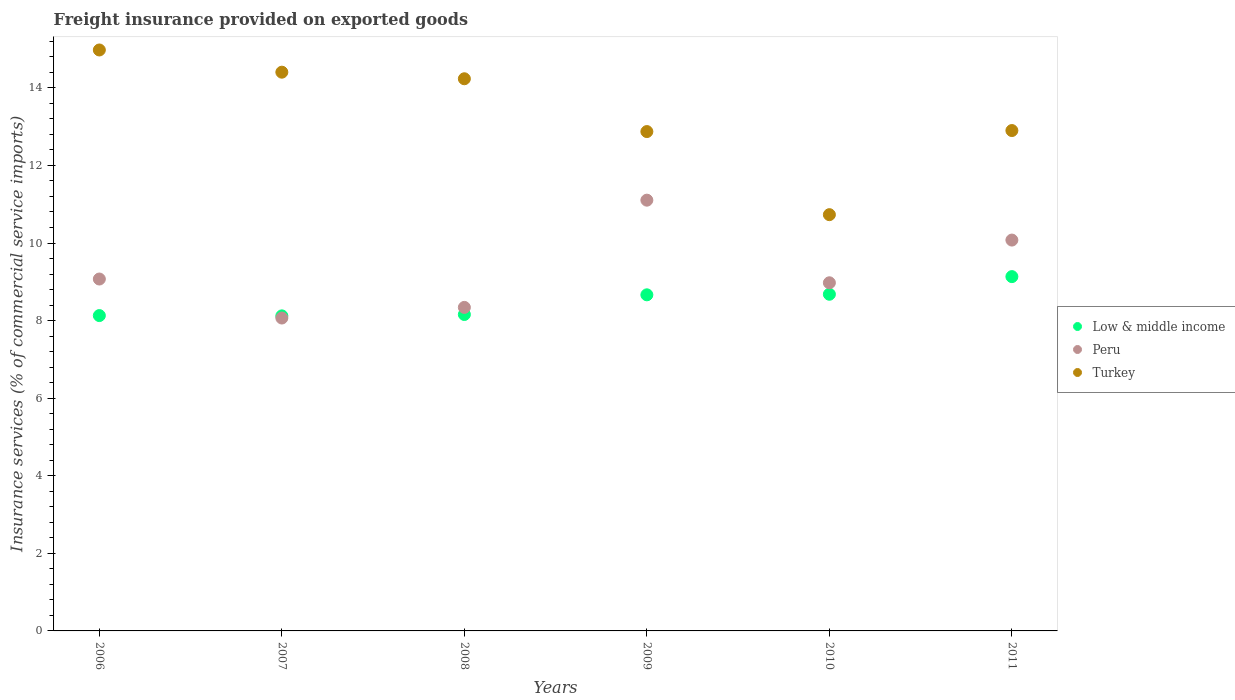What is the freight insurance provided on exported goods in Low & middle income in 2009?
Keep it short and to the point. 8.66. Across all years, what is the maximum freight insurance provided on exported goods in Low & middle income?
Make the answer very short. 9.13. Across all years, what is the minimum freight insurance provided on exported goods in Peru?
Make the answer very short. 8.07. What is the total freight insurance provided on exported goods in Peru in the graph?
Your response must be concise. 55.64. What is the difference between the freight insurance provided on exported goods in Peru in 2008 and that in 2010?
Offer a very short reply. -0.63. What is the difference between the freight insurance provided on exported goods in Turkey in 2006 and the freight insurance provided on exported goods in Peru in 2009?
Keep it short and to the point. 3.87. What is the average freight insurance provided on exported goods in Turkey per year?
Ensure brevity in your answer.  13.35. In the year 2009, what is the difference between the freight insurance provided on exported goods in Peru and freight insurance provided on exported goods in Low & middle income?
Ensure brevity in your answer.  2.44. What is the ratio of the freight insurance provided on exported goods in Peru in 2007 to that in 2009?
Your response must be concise. 0.73. Is the freight insurance provided on exported goods in Low & middle income in 2007 less than that in 2008?
Provide a succinct answer. Yes. What is the difference between the highest and the second highest freight insurance provided on exported goods in Turkey?
Offer a very short reply. 0.57. What is the difference between the highest and the lowest freight insurance provided on exported goods in Low & middle income?
Your answer should be very brief. 1.01. Is the sum of the freight insurance provided on exported goods in Peru in 2007 and 2010 greater than the maximum freight insurance provided on exported goods in Low & middle income across all years?
Make the answer very short. Yes. Does the freight insurance provided on exported goods in Low & middle income monotonically increase over the years?
Your answer should be compact. No. Is the freight insurance provided on exported goods in Low & middle income strictly greater than the freight insurance provided on exported goods in Turkey over the years?
Give a very brief answer. No. Does the graph contain any zero values?
Your answer should be compact. No. Does the graph contain grids?
Offer a very short reply. No. How are the legend labels stacked?
Make the answer very short. Vertical. What is the title of the graph?
Provide a succinct answer. Freight insurance provided on exported goods. Does "Isle of Man" appear as one of the legend labels in the graph?
Ensure brevity in your answer.  No. What is the label or title of the X-axis?
Offer a terse response. Years. What is the label or title of the Y-axis?
Your answer should be very brief. Insurance services (% of commercial service imports). What is the Insurance services (% of commercial service imports) of Low & middle income in 2006?
Offer a terse response. 8.13. What is the Insurance services (% of commercial service imports) of Peru in 2006?
Provide a short and direct response. 9.07. What is the Insurance services (% of commercial service imports) in Turkey in 2006?
Make the answer very short. 14.98. What is the Insurance services (% of commercial service imports) of Low & middle income in 2007?
Make the answer very short. 8.12. What is the Insurance services (% of commercial service imports) in Peru in 2007?
Your response must be concise. 8.07. What is the Insurance services (% of commercial service imports) in Turkey in 2007?
Provide a short and direct response. 14.4. What is the Insurance services (% of commercial service imports) in Low & middle income in 2008?
Your response must be concise. 8.16. What is the Insurance services (% of commercial service imports) of Peru in 2008?
Keep it short and to the point. 8.34. What is the Insurance services (% of commercial service imports) of Turkey in 2008?
Your answer should be compact. 14.23. What is the Insurance services (% of commercial service imports) of Low & middle income in 2009?
Make the answer very short. 8.66. What is the Insurance services (% of commercial service imports) of Peru in 2009?
Ensure brevity in your answer.  11.1. What is the Insurance services (% of commercial service imports) in Turkey in 2009?
Make the answer very short. 12.87. What is the Insurance services (% of commercial service imports) of Low & middle income in 2010?
Make the answer very short. 8.68. What is the Insurance services (% of commercial service imports) of Peru in 2010?
Ensure brevity in your answer.  8.98. What is the Insurance services (% of commercial service imports) in Turkey in 2010?
Offer a terse response. 10.73. What is the Insurance services (% of commercial service imports) of Low & middle income in 2011?
Provide a succinct answer. 9.13. What is the Insurance services (% of commercial service imports) of Peru in 2011?
Provide a succinct answer. 10.08. What is the Insurance services (% of commercial service imports) of Turkey in 2011?
Make the answer very short. 12.9. Across all years, what is the maximum Insurance services (% of commercial service imports) of Low & middle income?
Ensure brevity in your answer.  9.13. Across all years, what is the maximum Insurance services (% of commercial service imports) of Peru?
Give a very brief answer. 11.1. Across all years, what is the maximum Insurance services (% of commercial service imports) of Turkey?
Your answer should be very brief. 14.98. Across all years, what is the minimum Insurance services (% of commercial service imports) of Low & middle income?
Ensure brevity in your answer.  8.12. Across all years, what is the minimum Insurance services (% of commercial service imports) in Peru?
Provide a succinct answer. 8.07. Across all years, what is the minimum Insurance services (% of commercial service imports) of Turkey?
Your answer should be very brief. 10.73. What is the total Insurance services (% of commercial service imports) of Low & middle income in the graph?
Ensure brevity in your answer.  50.89. What is the total Insurance services (% of commercial service imports) of Peru in the graph?
Your answer should be compact. 55.64. What is the total Insurance services (% of commercial service imports) of Turkey in the graph?
Offer a very short reply. 80.12. What is the difference between the Insurance services (% of commercial service imports) of Low & middle income in 2006 and that in 2007?
Make the answer very short. 0.01. What is the difference between the Insurance services (% of commercial service imports) of Peru in 2006 and that in 2007?
Your answer should be very brief. 1.01. What is the difference between the Insurance services (% of commercial service imports) in Turkey in 2006 and that in 2007?
Provide a short and direct response. 0.57. What is the difference between the Insurance services (% of commercial service imports) of Low & middle income in 2006 and that in 2008?
Offer a very short reply. -0.03. What is the difference between the Insurance services (% of commercial service imports) in Peru in 2006 and that in 2008?
Ensure brevity in your answer.  0.73. What is the difference between the Insurance services (% of commercial service imports) in Turkey in 2006 and that in 2008?
Keep it short and to the point. 0.74. What is the difference between the Insurance services (% of commercial service imports) in Low & middle income in 2006 and that in 2009?
Keep it short and to the point. -0.54. What is the difference between the Insurance services (% of commercial service imports) in Peru in 2006 and that in 2009?
Your answer should be very brief. -2.03. What is the difference between the Insurance services (% of commercial service imports) of Turkey in 2006 and that in 2009?
Your answer should be very brief. 2.1. What is the difference between the Insurance services (% of commercial service imports) of Low & middle income in 2006 and that in 2010?
Your answer should be very brief. -0.55. What is the difference between the Insurance services (% of commercial service imports) of Peru in 2006 and that in 2010?
Offer a very short reply. 0.1. What is the difference between the Insurance services (% of commercial service imports) in Turkey in 2006 and that in 2010?
Provide a short and direct response. 4.25. What is the difference between the Insurance services (% of commercial service imports) in Low & middle income in 2006 and that in 2011?
Keep it short and to the point. -1. What is the difference between the Insurance services (% of commercial service imports) of Peru in 2006 and that in 2011?
Keep it short and to the point. -1. What is the difference between the Insurance services (% of commercial service imports) of Turkey in 2006 and that in 2011?
Keep it short and to the point. 2.08. What is the difference between the Insurance services (% of commercial service imports) of Low & middle income in 2007 and that in 2008?
Your response must be concise. -0.04. What is the difference between the Insurance services (% of commercial service imports) of Peru in 2007 and that in 2008?
Offer a very short reply. -0.27. What is the difference between the Insurance services (% of commercial service imports) of Turkey in 2007 and that in 2008?
Offer a very short reply. 0.17. What is the difference between the Insurance services (% of commercial service imports) in Low & middle income in 2007 and that in 2009?
Offer a terse response. -0.54. What is the difference between the Insurance services (% of commercial service imports) in Peru in 2007 and that in 2009?
Keep it short and to the point. -3.04. What is the difference between the Insurance services (% of commercial service imports) in Turkey in 2007 and that in 2009?
Your answer should be very brief. 1.53. What is the difference between the Insurance services (% of commercial service imports) in Low & middle income in 2007 and that in 2010?
Provide a succinct answer. -0.56. What is the difference between the Insurance services (% of commercial service imports) in Peru in 2007 and that in 2010?
Offer a very short reply. -0.91. What is the difference between the Insurance services (% of commercial service imports) of Turkey in 2007 and that in 2010?
Your response must be concise. 3.67. What is the difference between the Insurance services (% of commercial service imports) of Low & middle income in 2007 and that in 2011?
Offer a very short reply. -1.01. What is the difference between the Insurance services (% of commercial service imports) of Peru in 2007 and that in 2011?
Give a very brief answer. -2.01. What is the difference between the Insurance services (% of commercial service imports) in Turkey in 2007 and that in 2011?
Offer a terse response. 1.5. What is the difference between the Insurance services (% of commercial service imports) of Low & middle income in 2008 and that in 2009?
Provide a short and direct response. -0.51. What is the difference between the Insurance services (% of commercial service imports) of Peru in 2008 and that in 2009?
Provide a succinct answer. -2.76. What is the difference between the Insurance services (% of commercial service imports) of Turkey in 2008 and that in 2009?
Offer a terse response. 1.36. What is the difference between the Insurance services (% of commercial service imports) in Low & middle income in 2008 and that in 2010?
Offer a terse response. -0.52. What is the difference between the Insurance services (% of commercial service imports) of Peru in 2008 and that in 2010?
Make the answer very short. -0.63. What is the difference between the Insurance services (% of commercial service imports) in Turkey in 2008 and that in 2010?
Provide a succinct answer. 3.5. What is the difference between the Insurance services (% of commercial service imports) in Low & middle income in 2008 and that in 2011?
Your response must be concise. -0.98. What is the difference between the Insurance services (% of commercial service imports) in Peru in 2008 and that in 2011?
Provide a short and direct response. -1.74. What is the difference between the Insurance services (% of commercial service imports) of Turkey in 2008 and that in 2011?
Your answer should be very brief. 1.33. What is the difference between the Insurance services (% of commercial service imports) of Low & middle income in 2009 and that in 2010?
Your answer should be very brief. -0.01. What is the difference between the Insurance services (% of commercial service imports) of Peru in 2009 and that in 2010?
Give a very brief answer. 2.13. What is the difference between the Insurance services (% of commercial service imports) of Turkey in 2009 and that in 2010?
Make the answer very short. 2.14. What is the difference between the Insurance services (% of commercial service imports) of Low & middle income in 2009 and that in 2011?
Your answer should be compact. -0.47. What is the difference between the Insurance services (% of commercial service imports) in Peru in 2009 and that in 2011?
Provide a succinct answer. 1.03. What is the difference between the Insurance services (% of commercial service imports) in Turkey in 2009 and that in 2011?
Your answer should be very brief. -0.03. What is the difference between the Insurance services (% of commercial service imports) in Low & middle income in 2010 and that in 2011?
Provide a short and direct response. -0.45. What is the difference between the Insurance services (% of commercial service imports) in Peru in 2010 and that in 2011?
Make the answer very short. -1.1. What is the difference between the Insurance services (% of commercial service imports) in Turkey in 2010 and that in 2011?
Your answer should be very brief. -2.17. What is the difference between the Insurance services (% of commercial service imports) of Low & middle income in 2006 and the Insurance services (% of commercial service imports) of Peru in 2007?
Your answer should be very brief. 0.06. What is the difference between the Insurance services (% of commercial service imports) in Low & middle income in 2006 and the Insurance services (% of commercial service imports) in Turkey in 2007?
Make the answer very short. -6.27. What is the difference between the Insurance services (% of commercial service imports) of Peru in 2006 and the Insurance services (% of commercial service imports) of Turkey in 2007?
Your answer should be compact. -5.33. What is the difference between the Insurance services (% of commercial service imports) of Low & middle income in 2006 and the Insurance services (% of commercial service imports) of Peru in 2008?
Offer a terse response. -0.21. What is the difference between the Insurance services (% of commercial service imports) in Low & middle income in 2006 and the Insurance services (% of commercial service imports) in Turkey in 2008?
Your answer should be compact. -6.11. What is the difference between the Insurance services (% of commercial service imports) in Peru in 2006 and the Insurance services (% of commercial service imports) in Turkey in 2008?
Make the answer very short. -5.16. What is the difference between the Insurance services (% of commercial service imports) in Low & middle income in 2006 and the Insurance services (% of commercial service imports) in Peru in 2009?
Give a very brief answer. -2.98. What is the difference between the Insurance services (% of commercial service imports) in Low & middle income in 2006 and the Insurance services (% of commercial service imports) in Turkey in 2009?
Make the answer very short. -4.74. What is the difference between the Insurance services (% of commercial service imports) of Peru in 2006 and the Insurance services (% of commercial service imports) of Turkey in 2009?
Provide a short and direct response. -3.8. What is the difference between the Insurance services (% of commercial service imports) in Low & middle income in 2006 and the Insurance services (% of commercial service imports) in Peru in 2010?
Keep it short and to the point. -0.85. What is the difference between the Insurance services (% of commercial service imports) in Low & middle income in 2006 and the Insurance services (% of commercial service imports) in Turkey in 2010?
Ensure brevity in your answer.  -2.6. What is the difference between the Insurance services (% of commercial service imports) in Peru in 2006 and the Insurance services (% of commercial service imports) in Turkey in 2010?
Provide a short and direct response. -1.66. What is the difference between the Insurance services (% of commercial service imports) in Low & middle income in 2006 and the Insurance services (% of commercial service imports) in Peru in 2011?
Ensure brevity in your answer.  -1.95. What is the difference between the Insurance services (% of commercial service imports) of Low & middle income in 2006 and the Insurance services (% of commercial service imports) of Turkey in 2011?
Offer a terse response. -4.77. What is the difference between the Insurance services (% of commercial service imports) of Peru in 2006 and the Insurance services (% of commercial service imports) of Turkey in 2011?
Offer a terse response. -3.83. What is the difference between the Insurance services (% of commercial service imports) in Low & middle income in 2007 and the Insurance services (% of commercial service imports) in Peru in 2008?
Your response must be concise. -0.22. What is the difference between the Insurance services (% of commercial service imports) of Low & middle income in 2007 and the Insurance services (% of commercial service imports) of Turkey in 2008?
Your answer should be compact. -6.11. What is the difference between the Insurance services (% of commercial service imports) of Peru in 2007 and the Insurance services (% of commercial service imports) of Turkey in 2008?
Your answer should be compact. -6.17. What is the difference between the Insurance services (% of commercial service imports) in Low & middle income in 2007 and the Insurance services (% of commercial service imports) in Peru in 2009?
Keep it short and to the point. -2.98. What is the difference between the Insurance services (% of commercial service imports) in Low & middle income in 2007 and the Insurance services (% of commercial service imports) in Turkey in 2009?
Your answer should be compact. -4.75. What is the difference between the Insurance services (% of commercial service imports) of Peru in 2007 and the Insurance services (% of commercial service imports) of Turkey in 2009?
Offer a very short reply. -4.81. What is the difference between the Insurance services (% of commercial service imports) in Low & middle income in 2007 and the Insurance services (% of commercial service imports) in Peru in 2010?
Your response must be concise. -0.85. What is the difference between the Insurance services (% of commercial service imports) of Low & middle income in 2007 and the Insurance services (% of commercial service imports) of Turkey in 2010?
Provide a succinct answer. -2.61. What is the difference between the Insurance services (% of commercial service imports) of Peru in 2007 and the Insurance services (% of commercial service imports) of Turkey in 2010?
Provide a short and direct response. -2.66. What is the difference between the Insurance services (% of commercial service imports) in Low & middle income in 2007 and the Insurance services (% of commercial service imports) in Peru in 2011?
Offer a terse response. -1.95. What is the difference between the Insurance services (% of commercial service imports) of Low & middle income in 2007 and the Insurance services (% of commercial service imports) of Turkey in 2011?
Offer a very short reply. -4.78. What is the difference between the Insurance services (% of commercial service imports) in Peru in 2007 and the Insurance services (% of commercial service imports) in Turkey in 2011?
Keep it short and to the point. -4.83. What is the difference between the Insurance services (% of commercial service imports) of Low & middle income in 2008 and the Insurance services (% of commercial service imports) of Peru in 2009?
Offer a very short reply. -2.95. What is the difference between the Insurance services (% of commercial service imports) in Low & middle income in 2008 and the Insurance services (% of commercial service imports) in Turkey in 2009?
Offer a very short reply. -4.72. What is the difference between the Insurance services (% of commercial service imports) in Peru in 2008 and the Insurance services (% of commercial service imports) in Turkey in 2009?
Your answer should be very brief. -4.53. What is the difference between the Insurance services (% of commercial service imports) in Low & middle income in 2008 and the Insurance services (% of commercial service imports) in Peru in 2010?
Make the answer very short. -0.82. What is the difference between the Insurance services (% of commercial service imports) in Low & middle income in 2008 and the Insurance services (% of commercial service imports) in Turkey in 2010?
Your response must be concise. -2.57. What is the difference between the Insurance services (% of commercial service imports) of Peru in 2008 and the Insurance services (% of commercial service imports) of Turkey in 2010?
Offer a very short reply. -2.39. What is the difference between the Insurance services (% of commercial service imports) of Low & middle income in 2008 and the Insurance services (% of commercial service imports) of Peru in 2011?
Provide a succinct answer. -1.92. What is the difference between the Insurance services (% of commercial service imports) in Low & middle income in 2008 and the Insurance services (% of commercial service imports) in Turkey in 2011?
Give a very brief answer. -4.74. What is the difference between the Insurance services (% of commercial service imports) in Peru in 2008 and the Insurance services (% of commercial service imports) in Turkey in 2011?
Provide a short and direct response. -4.56. What is the difference between the Insurance services (% of commercial service imports) in Low & middle income in 2009 and the Insurance services (% of commercial service imports) in Peru in 2010?
Offer a very short reply. -0.31. What is the difference between the Insurance services (% of commercial service imports) in Low & middle income in 2009 and the Insurance services (% of commercial service imports) in Turkey in 2010?
Keep it short and to the point. -2.07. What is the difference between the Insurance services (% of commercial service imports) of Peru in 2009 and the Insurance services (% of commercial service imports) of Turkey in 2010?
Provide a short and direct response. 0.37. What is the difference between the Insurance services (% of commercial service imports) of Low & middle income in 2009 and the Insurance services (% of commercial service imports) of Peru in 2011?
Make the answer very short. -1.41. What is the difference between the Insurance services (% of commercial service imports) of Low & middle income in 2009 and the Insurance services (% of commercial service imports) of Turkey in 2011?
Your answer should be very brief. -4.24. What is the difference between the Insurance services (% of commercial service imports) in Peru in 2009 and the Insurance services (% of commercial service imports) in Turkey in 2011?
Make the answer very short. -1.79. What is the difference between the Insurance services (% of commercial service imports) of Low & middle income in 2010 and the Insurance services (% of commercial service imports) of Peru in 2011?
Your response must be concise. -1.4. What is the difference between the Insurance services (% of commercial service imports) in Low & middle income in 2010 and the Insurance services (% of commercial service imports) in Turkey in 2011?
Provide a succinct answer. -4.22. What is the difference between the Insurance services (% of commercial service imports) in Peru in 2010 and the Insurance services (% of commercial service imports) in Turkey in 2011?
Offer a terse response. -3.92. What is the average Insurance services (% of commercial service imports) of Low & middle income per year?
Ensure brevity in your answer.  8.48. What is the average Insurance services (% of commercial service imports) in Peru per year?
Offer a terse response. 9.27. What is the average Insurance services (% of commercial service imports) in Turkey per year?
Your answer should be very brief. 13.35. In the year 2006, what is the difference between the Insurance services (% of commercial service imports) of Low & middle income and Insurance services (% of commercial service imports) of Peru?
Your response must be concise. -0.94. In the year 2006, what is the difference between the Insurance services (% of commercial service imports) of Low & middle income and Insurance services (% of commercial service imports) of Turkey?
Ensure brevity in your answer.  -6.85. In the year 2006, what is the difference between the Insurance services (% of commercial service imports) in Peru and Insurance services (% of commercial service imports) in Turkey?
Ensure brevity in your answer.  -5.9. In the year 2007, what is the difference between the Insurance services (% of commercial service imports) of Low & middle income and Insurance services (% of commercial service imports) of Peru?
Ensure brevity in your answer.  0.06. In the year 2007, what is the difference between the Insurance services (% of commercial service imports) of Low & middle income and Insurance services (% of commercial service imports) of Turkey?
Provide a succinct answer. -6.28. In the year 2007, what is the difference between the Insurance services (% of commercial service imports) of Peru and Insurance services (% of commercial service imports) of Turkey?
Offer a terse response. -6.34. In the year 2008, what is the difference between the Insurance services (% of commercial service imports) of Low & middle income and Insurance services (% of commercial service imports) of Peru?
Provide a succinct answer. -0.18. In the year 2008, what is the difference between the Insurance services (% of commercial service imports) of Low & middle income and Insurance services (% of commercial service imports) of Turkey?
Your response must be concise. -6.08. In the year 2008, what is the difference between the Insurance services (% of commercial service imports) in Peru and Insurance services (% of commercial service imports) in Turkey?
Offer a terse response. -5.89. In the year 2009, what is the difference between the Insurance services (% of commercial service imports) in Low & middle income and Insurance services (% of commercial service imports) in Peru?
Offer a very short reply. -2.44. In the year 2009, what is the difference between the Insurance services (% of commercial service imports) of Low & middle income and Insurance services (% of commercial service imports) of Turkey?
Make the answer very short. -4.21. In the year 2009, what is the difference between the Insurance services (% of commercial service imports) in Peru and Insurance services (% of commercial service imports) in Turkey?
Make the answer very short. -1.77. In the year 2010, what is the difference between the Insurance services (% of commercial service imports) in Low & middle income and Insurance services (% of commercial service imports) in Peru?
Keep it short and to the point. -0.3. In the year 2010, what is the difference between the Insurance services (% of commercial service imports) of Low & middle income and Insurance services (% of commercial service imports) of Turkey?
Provide a succinct answer. -2.05. In the year 2010, what is the difference between the Insurance services (% of commercial service imports) of Peru and Insurance services (% of commercial service imports) of Turkey?
Provide a succinct answer. -1.76. In the year 2011, what is the difference between the Insurance services (% of commercial service imports) of Low & middle income and Insurance services (% of commercial service imports) of Peru?
Offer a terse response. -0.94. In the year 2011, what is the difference between the Insurance services (% of commercial service imports) in Low & middle income and Insurance services (% of commercial service imports) in Turkey?
Offer a very short reply. -3.77. In the year 2011, what is the difference between the Insurance services (% of commercial service imports) of Peru and Insurance services (% of commercial service imports) of Turkey?
Ensure brevity in your answer.  -2.82. What is the ratio of the Insurance services (% of commercial service imports) of Peru in 2006 to that in 2007?
Your answer should be compact. 1.12. What is the ratio of the Insurance services (% of commercial service imports) in Turkey in 2006 to that in 2007?
Your answer should be very brief. 1.04. What is the ratio of the Insurance services (% of commercial service imports) of Peru in 2006 to that in 2008?
Your answer should be very brief. 1.09. What is the ratio of the Insurance services (% of commercial service imports) of Turkey in 2006 to that in 2008?
Ensure brevity in your answer.  1.05. What is the ratio of the Insurance services (% of commercial service imports) in Low & middle income in 2006 to that in 2009?
Your answer should be very brief. 0.94. What is the ratio of the Insurance services (% of commercial service imports) of Peru in 2006 to that in 2009?
Ensure brevity in your answer.  0.82. What is the ratio of the Insurance services (% of commercial service imports) in Turkey in 2006 to that in 2009?
Offer a very short reply. 1.16. What is the ratio of the Insurance services (% of commercial service imports) of Low & middle income in 2006 to that in 2010?
Provide a succinct answer. 0.94. What is the ratio of the Insurance services (% of commercial service imports) of Peru in 2006 to that in 2010?
Make the answer very short. 1.01. What is the ratio of the Insurance services (% of commercial service imports) of Turkey in 2006 to that in 2010?
Your answer should be compact. 1.4. What is the ratio of the Insurance services (% of commercial service imports) in Low & middle income in 2006 to that in 2011?
Give a very brief answer. 0.89. What is the ratio of the Insurance services (% of commercial service imports) of Peru in 2006 to that in 2011?
Your answer should be compact. 0.9. What is the ratio of the Insurance services (% of commercial service imports) in Turkey in 2006 to that in 2011?
Offer a very short reply. 1.16. What is the ratio of the Insurance services (% of commercial service imports) of Low & middle income in 2007 to that in 2008?
Provide a succinct answer. 1. What is the ratio of the Insurance services (% of commercial service imports) in Peru in 2007 to that in 2008?
Keep it short and to the point. 0.97. What is the ratio of the Insurance services (% of commercial service imports) of Turkey in 2007 to that in 2008?
Keep it short and to the point. 1.01. What is the ratio of the Insurance services (% of commercial service imports) in Low & middle income in 2007 to that in 2009?
Ensure brevity in your answer.  0.94. What is the ratio of the Insurance services (% of commercial service imports) of Peru in 2007 to that in 2009?
Give a very brief answer. 0.73. What is the ratio of the Insurance services (% of commercial service imports) in Turkey in 2007 to that in 2009?
Give a very brief answer. 1.12. What is the ratio of the Insurance services (% of commercial service imports) in Low & middle income in 2007 to that in 2010?
Give a very brief answer. 0.94. What is the ratio of the Insurance services (% of commercial service imports) of Peru in 2007 to that in 2010?
Provide a short and direct response. 0.9. What is the ratio of the Insurance services (% of commercial service imports) in Turkey in 2007 to that in 2010?
Keep it short and to the point. 1.34. What is the ratio of the Insurance services (% of commercial service imports) in Low & middle income in 2007 to that in 2011?
Your answer should be very brief. 0.89. What is the ratio of the Insurance services (% of commercial service imports) of Peru in 2007 to that in 2011?
Keep it short and to the point. 0.8. What is the ratio of the Insurance services (% of commercial service imports) of Turkey in 2007 to that in 2011?
Make the answer very short. 1.12. What is the ratio of the Insurance services (% of commercial service imports) of Low & middle income in 2008 to that in 2009?
Offer a very short reply. 0.94. What is the ratio of the Insurance services (% of commercial service imports) in Peru in 2008 to that in 2009?
Provide a succinct answer. 0.75. What is the ratio of the Insurance services (% of commercial service imports) of Turkey in 2008 to that in 2009?
Make the answer very short. 1.11. What is the ratio of the Insurance services (% of commercial service imports) in Low & middle income in 2008 to that in 2010?
Offer a terse response. 0.94. What is the ratio of the Insurance services (% of commercial service imports) of Peru in 2008 to that in 2010?
Provide a succinct answer. 0.93. What is the ratio of the Insurance services (% of commercial service imports) in Turkey in 2008 to that in 2010?
Your answer should be compact. 1.33. What is the ratio of the Insurance services (% of commercial service imports) in Low & middle income in 2008 to that in 2011?
Make the answer very short. 0.89. What is the ratio of the Insurance services (% of commercial service imports) of Peru in 2008 to that in 2011?
Ensure brevity in your answer.  0.83. What is the ratio of the Insurance services (% of commercial service imports) in Turkey in 2008 to that in 2011?
Offer a terse response. 1.1. What is the ratio of the Insurance services (% of commercial service imports) in Low & middle income in 2009 to that in 2010?
Give a very brief answer. 1. What is the ratio of the Insurance services (% of commercial service imports) of Peru in 2009 to that in 2010?
Make the answer very short. 1.24. What is the ratio of the Insurance services (% of commercial service imports) in Turkey in 2009 to that in 2010?
Your answer should be compact. 1.2. What is the ratio of the Insurance services (% of commercial service imports) of Low & middle income in 2009 to that in 2011?
Provide a succinct answer. 0.95. What is the ratio of the Insurance services (% of commercial service imports) in Peru in 2009 to that in 2011?
Provide a succinct answer. 1.1. What is the ratio of the Insurance services (% of commercial service imports) in Turkey in 2009 to that in 2011?
Give a very brief answer. 1. What is the ratio of the Insurance services (% of commercial service imports) of Low & middle income in 2010 to that in 2011?
Offer a very short reply. 0.95. What is the ratio of the Insurance services (% of commercial service imports) of Peru in 2010 to that in 2011?
Your answer should be very brief. 0.89. What is the ratio of the Insurance services (% of commercial service imports) in Turkey in 2010 to that in 2011?
Ensure brevity in your answer.  0.83. What is the difference between the highest and the second highest Insurance services (% of commercial service imports) in Low & middle income?
Offer a terse response. 0.45. What is the difference between the highest and the second highest Insurance services (% of commercial service imports) of Peru?
Your answer should be compact. 1.03. What is the difference between the highest and the second highest Insurance services (% of commercial service imports) in Turkey?
Keep it short and to the point. 0.57. What is the difference between the highest and the lowest Insurance services (% of commercial service imports) of Low & middle income?
Your answer should be compact. 1.01. What is the difference between the highest and the lowest Insurance services (% of commercial service imports) of Peru?
Make the answer very short. 3.04. What is the difference between the highest and the lowest Insurance services (% of commercial service imports) in Turkey?
Give a very brief answer. 4.25. 